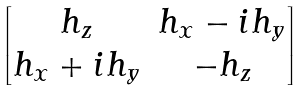Convert formula to latex. <formula><loc_0><loc_0><loc_500><loc_500>\begin{bmatrix} h _ { z } & h _ { x } - i h _ { y } \\ h _ { x } + i h _ { y } & - h _ { z } \end{bmatrix}</formula> 